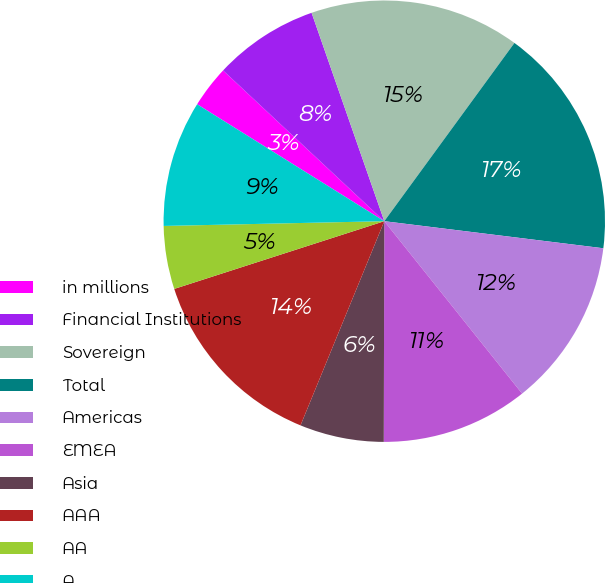Convert chart to OTSL. <chart><loc_0><loc_0><loc_500><loc_500><pie_chart><fcel>in millions<fcel>Financial Institutions<fcel>Sovereign<fcel>Total<fcel>Americas<fcel>EMEA<fcel>Asia<fcel>AAA<fcel>AA<fcel>A<nl><fcel>3.08%<fcel>7.69%<fcel>15.38%<fcel>16.92%<fcel>12.31%<fcel>10.77%<fcel>6.16%<fcel>13.84%<fcel>4.62%<fcel>9.23%<nl></chart> 